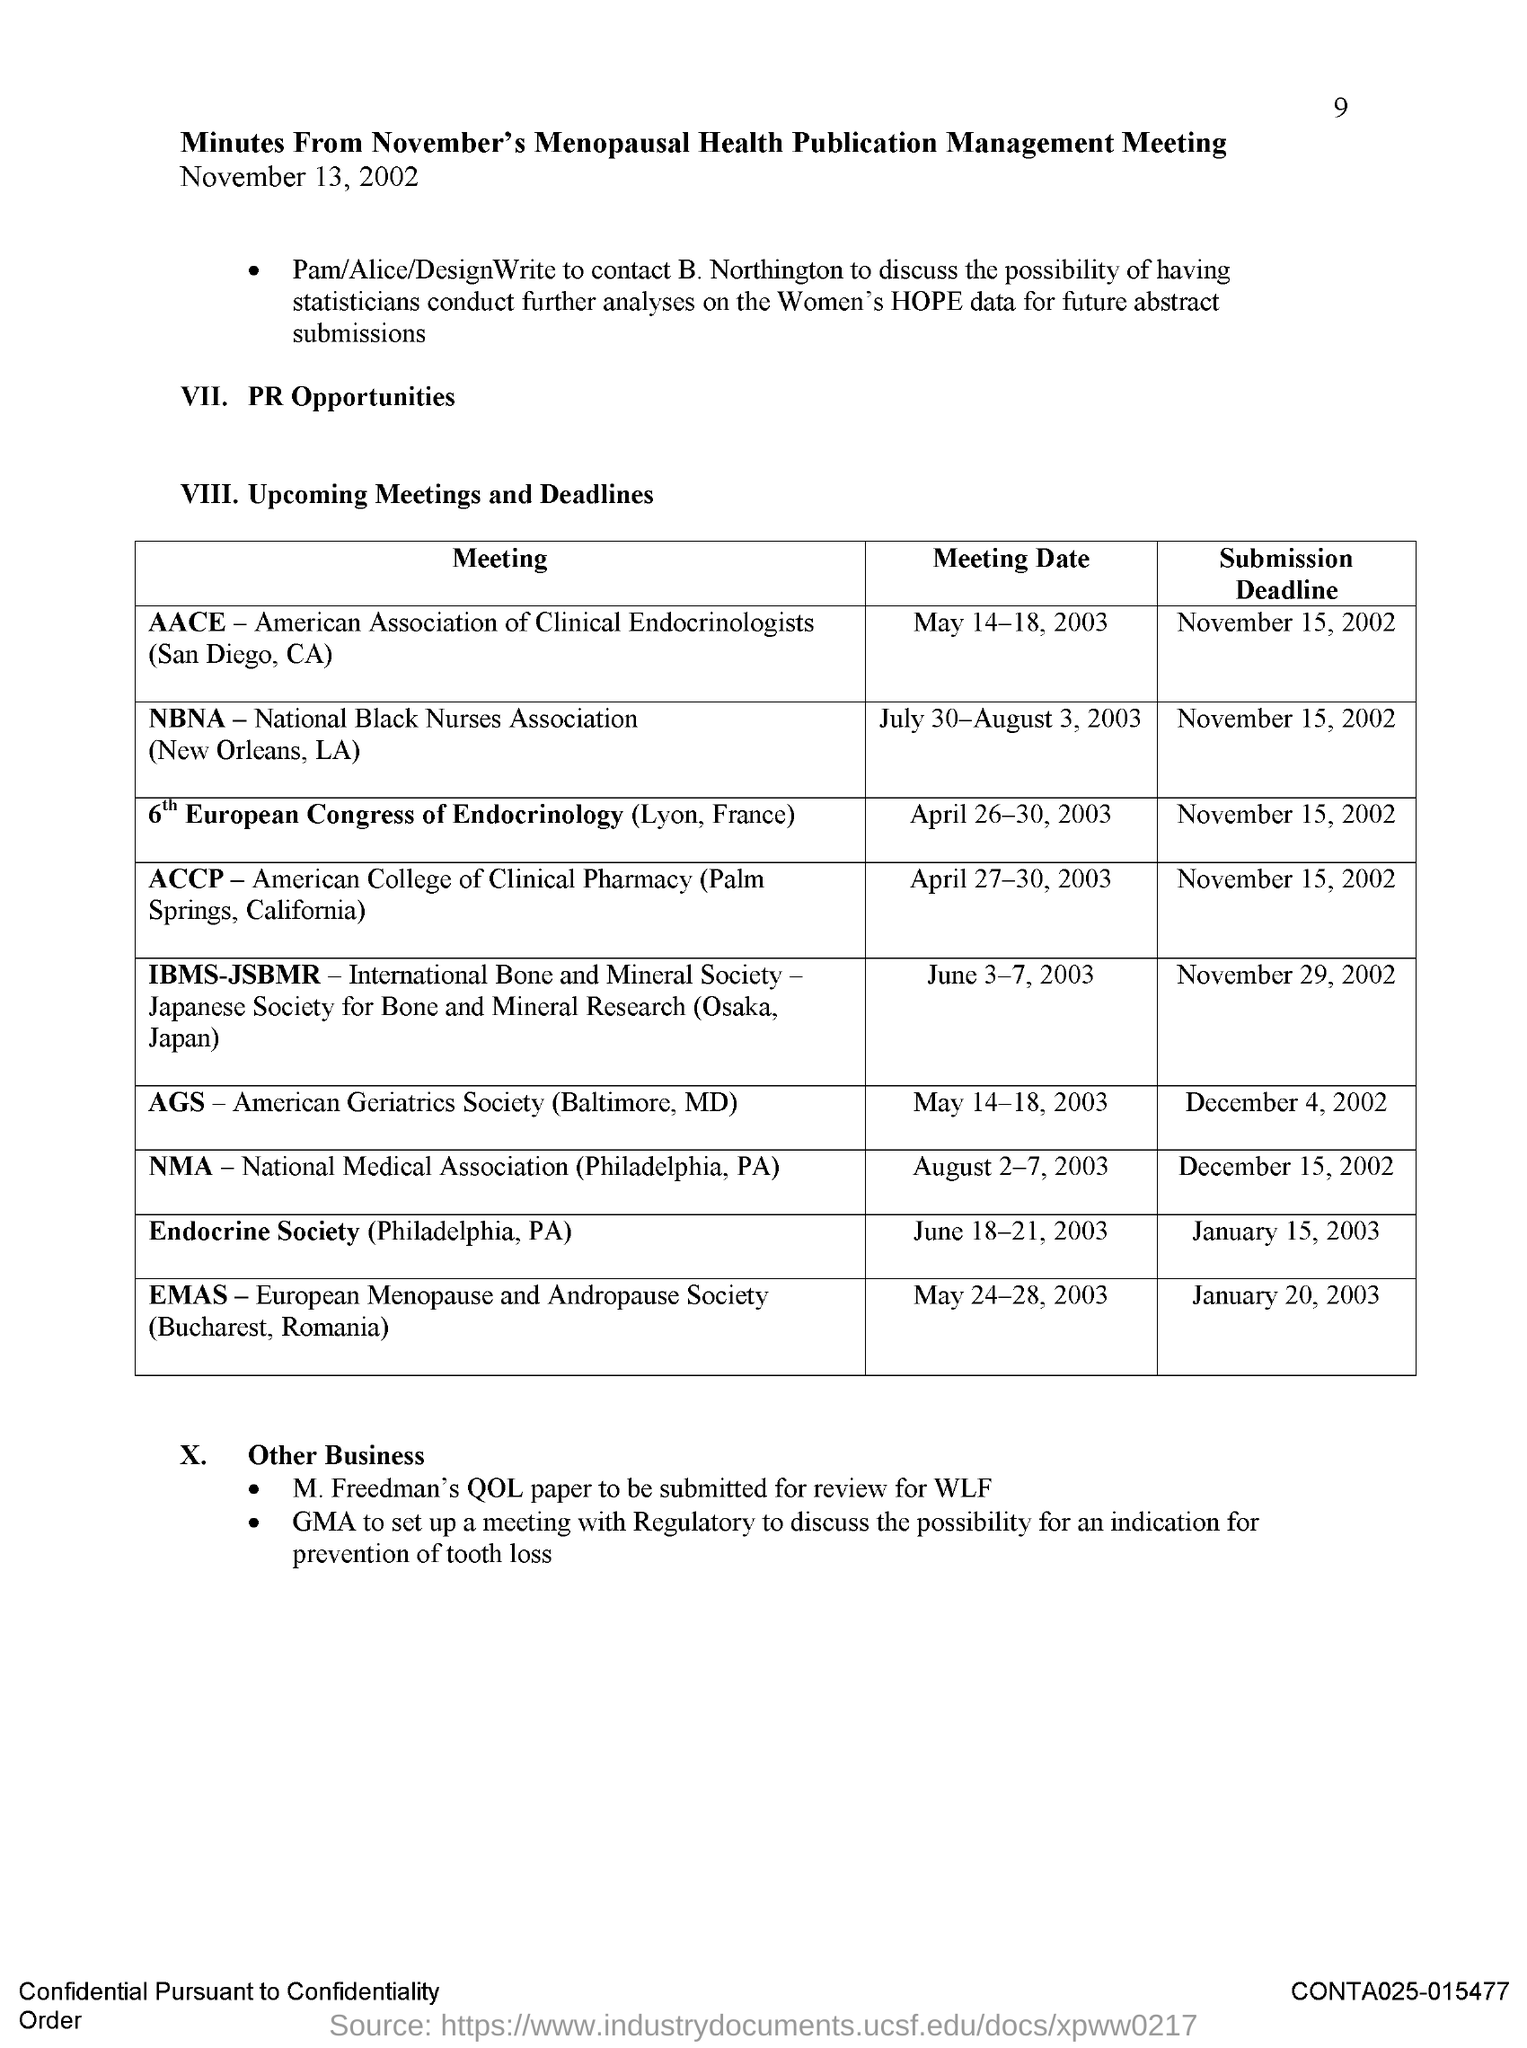Draw attention to some important aspects in this diagram. The submission deadline for the NMA (Philadelphia, PA) meeting is December 15, 2002. The meeting date of NBNA (New Orleans, LA) is July 30-August 3, 2003. The submission deadline for the Endocrine Society meeting, which took place in Philadelphia, Pennsylvania on January 15, 2003, has passed. The full form of NBNA is the National Black Nurses Association, which was established in New Orleans, Louisiana. This association is dedicated to promoting the health and well-being of Black nurses and their communities. The meeting date of AACE (San Diego, CA) was May 14-18, 2003. 